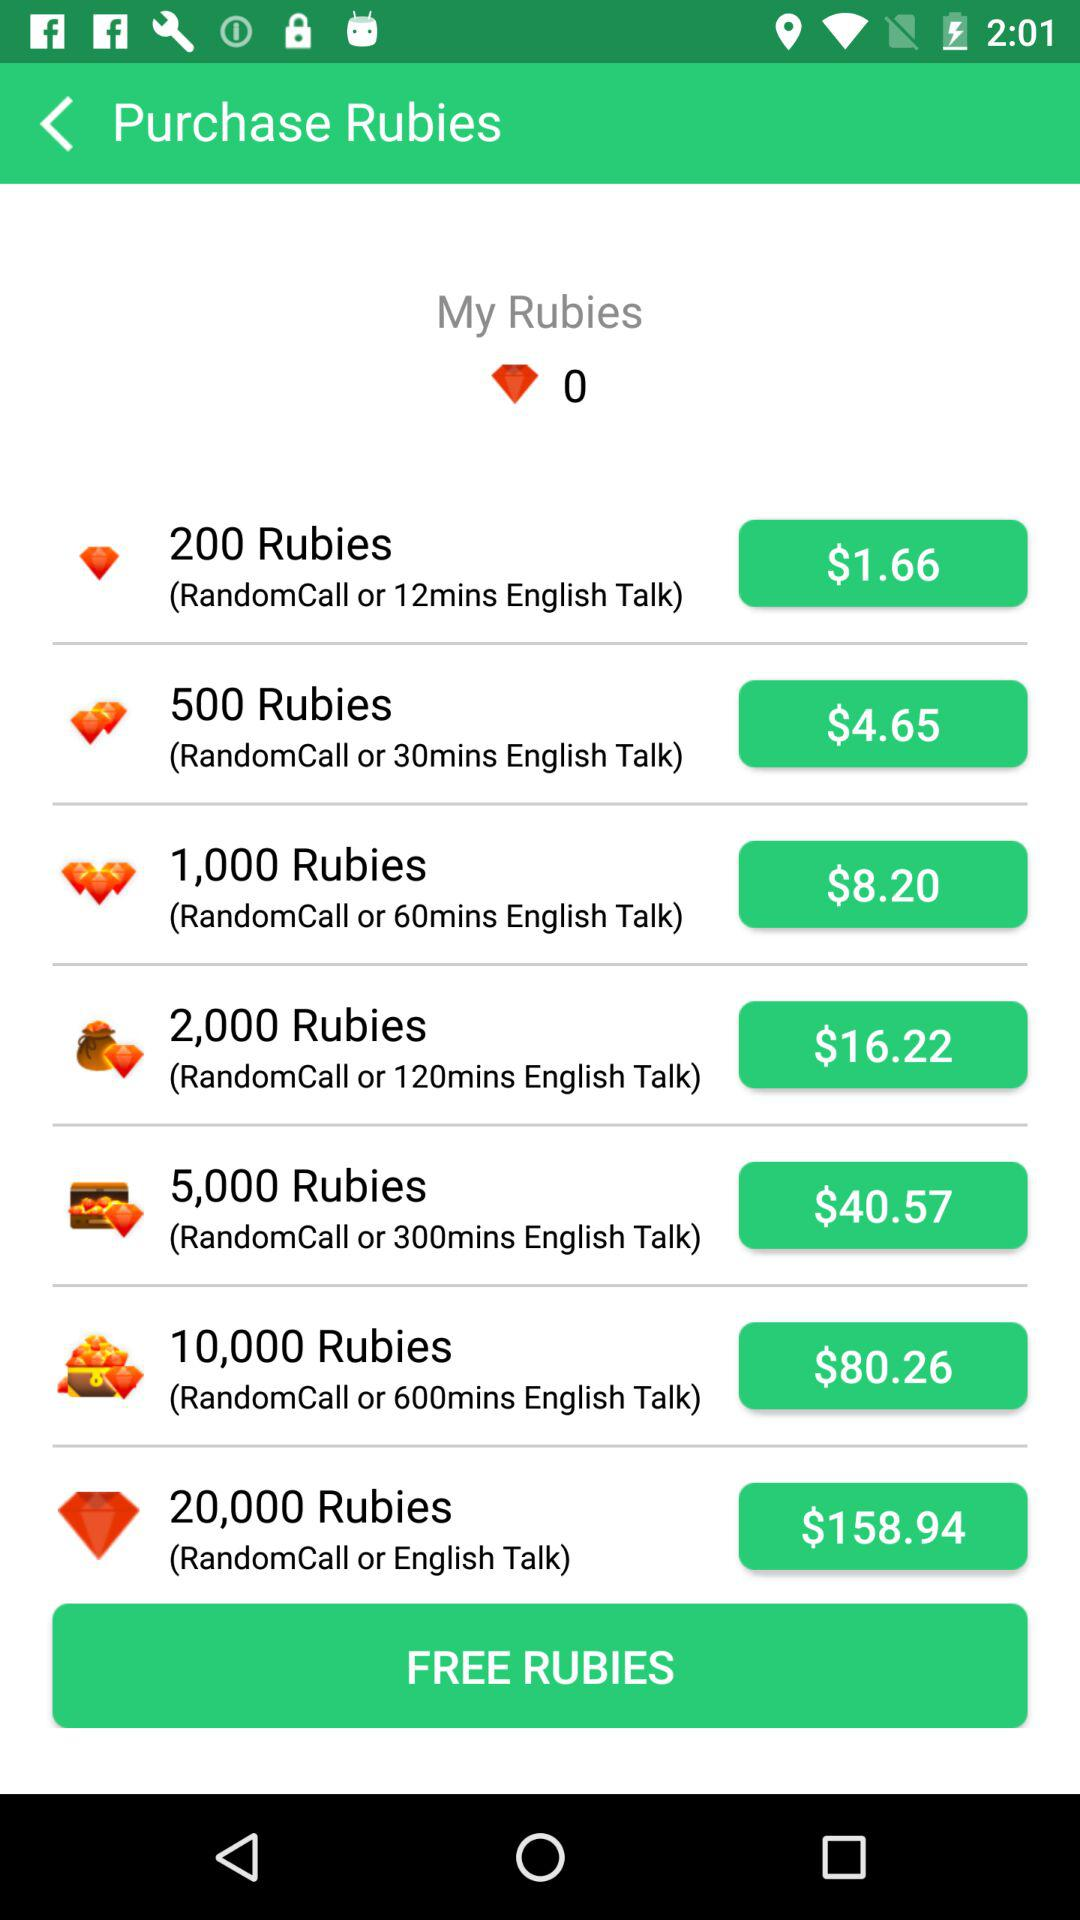How much are 200 rubies worth? The cost of 200 rubies is $1.66. 